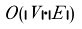Convert formula to latex. <formula><loc_0><loc_0><loc_500><loc_500>O ( | V | \cdot | E | )</formula> 